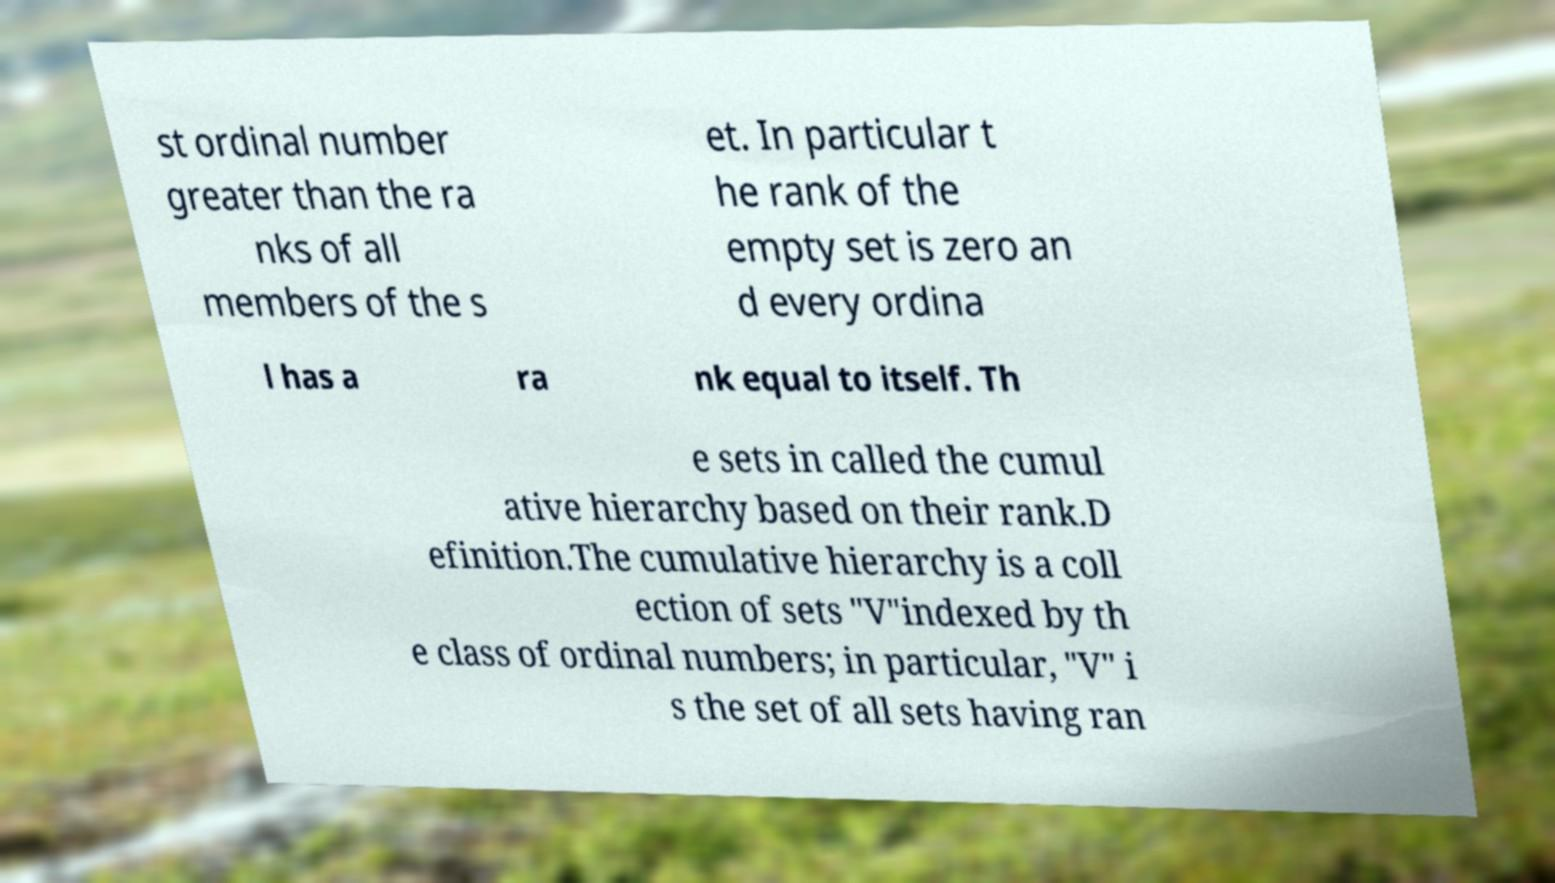What messages or text are displayed in this image? I need them in a readable, typed format. st ordinal number greater than the ra nks of all members of the s et. In particular t he rank of the empty set is zero an d every ordina l has a ra nk equal to itself. Th e sets in called the cumul ative hierarchy based on their rank.D efinition.The cumulative hierarchy is a coll ection of sets "V"indexed by th e class of ordinal numbers; in particular, "V" i s the set of all sets having ran 